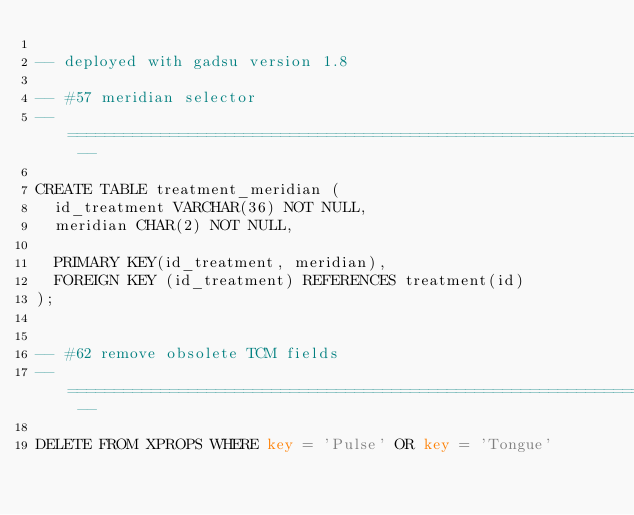<code> <loc_0><loc_0><loc_500><loc_500><_SQL_>
-- deployed with gadsu version 1.8

-- #57 meridian selector
-- ========================================================================= --

CREATE TABLE treatment_meridian (
  id_treatment VARCHAR(36) NOT NULL,
  meridian CHAR(2) NOT NULL,

  PRIMARY KEY(id_treatment, meridian),
  FOREIGN KEY (id_treatment) REFERENCES treatment(id)
);


-- #62 remove obsolete TCM fields
-- ========================================================================= --

DELETE FROM XPROPS WHERE key = 'Pulse' OR key = 'Tongue'
</code> 